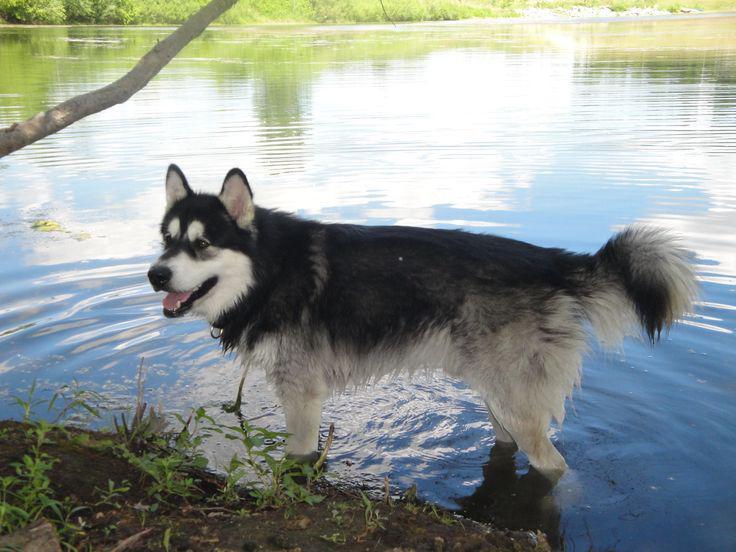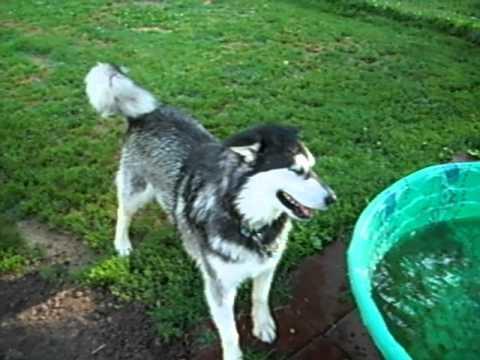The first image is the image on the left, the second image is the image on the right. Assess this claim about the two images: "All of the dogs are in the water.". Correct or not? Answer yes or no. No. The first image is the image on the left, the second image is the image on the right. Examine the images to the left and right. Is the description "Each image shows a dog in the water, with one of the dog's pictured facing directly forward and wearing a red collar." accurate? Answer yes or no. No. 